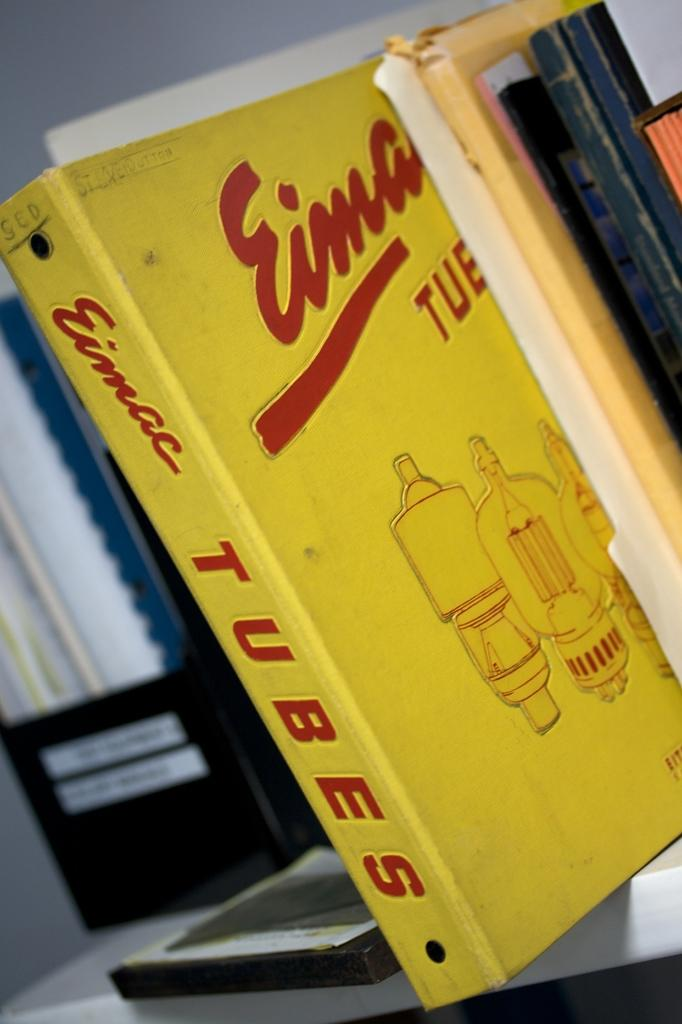<image>
Render a clear and concise summary of the photo. A yellow binder sits on a shelf with Tubes written on the spine. 